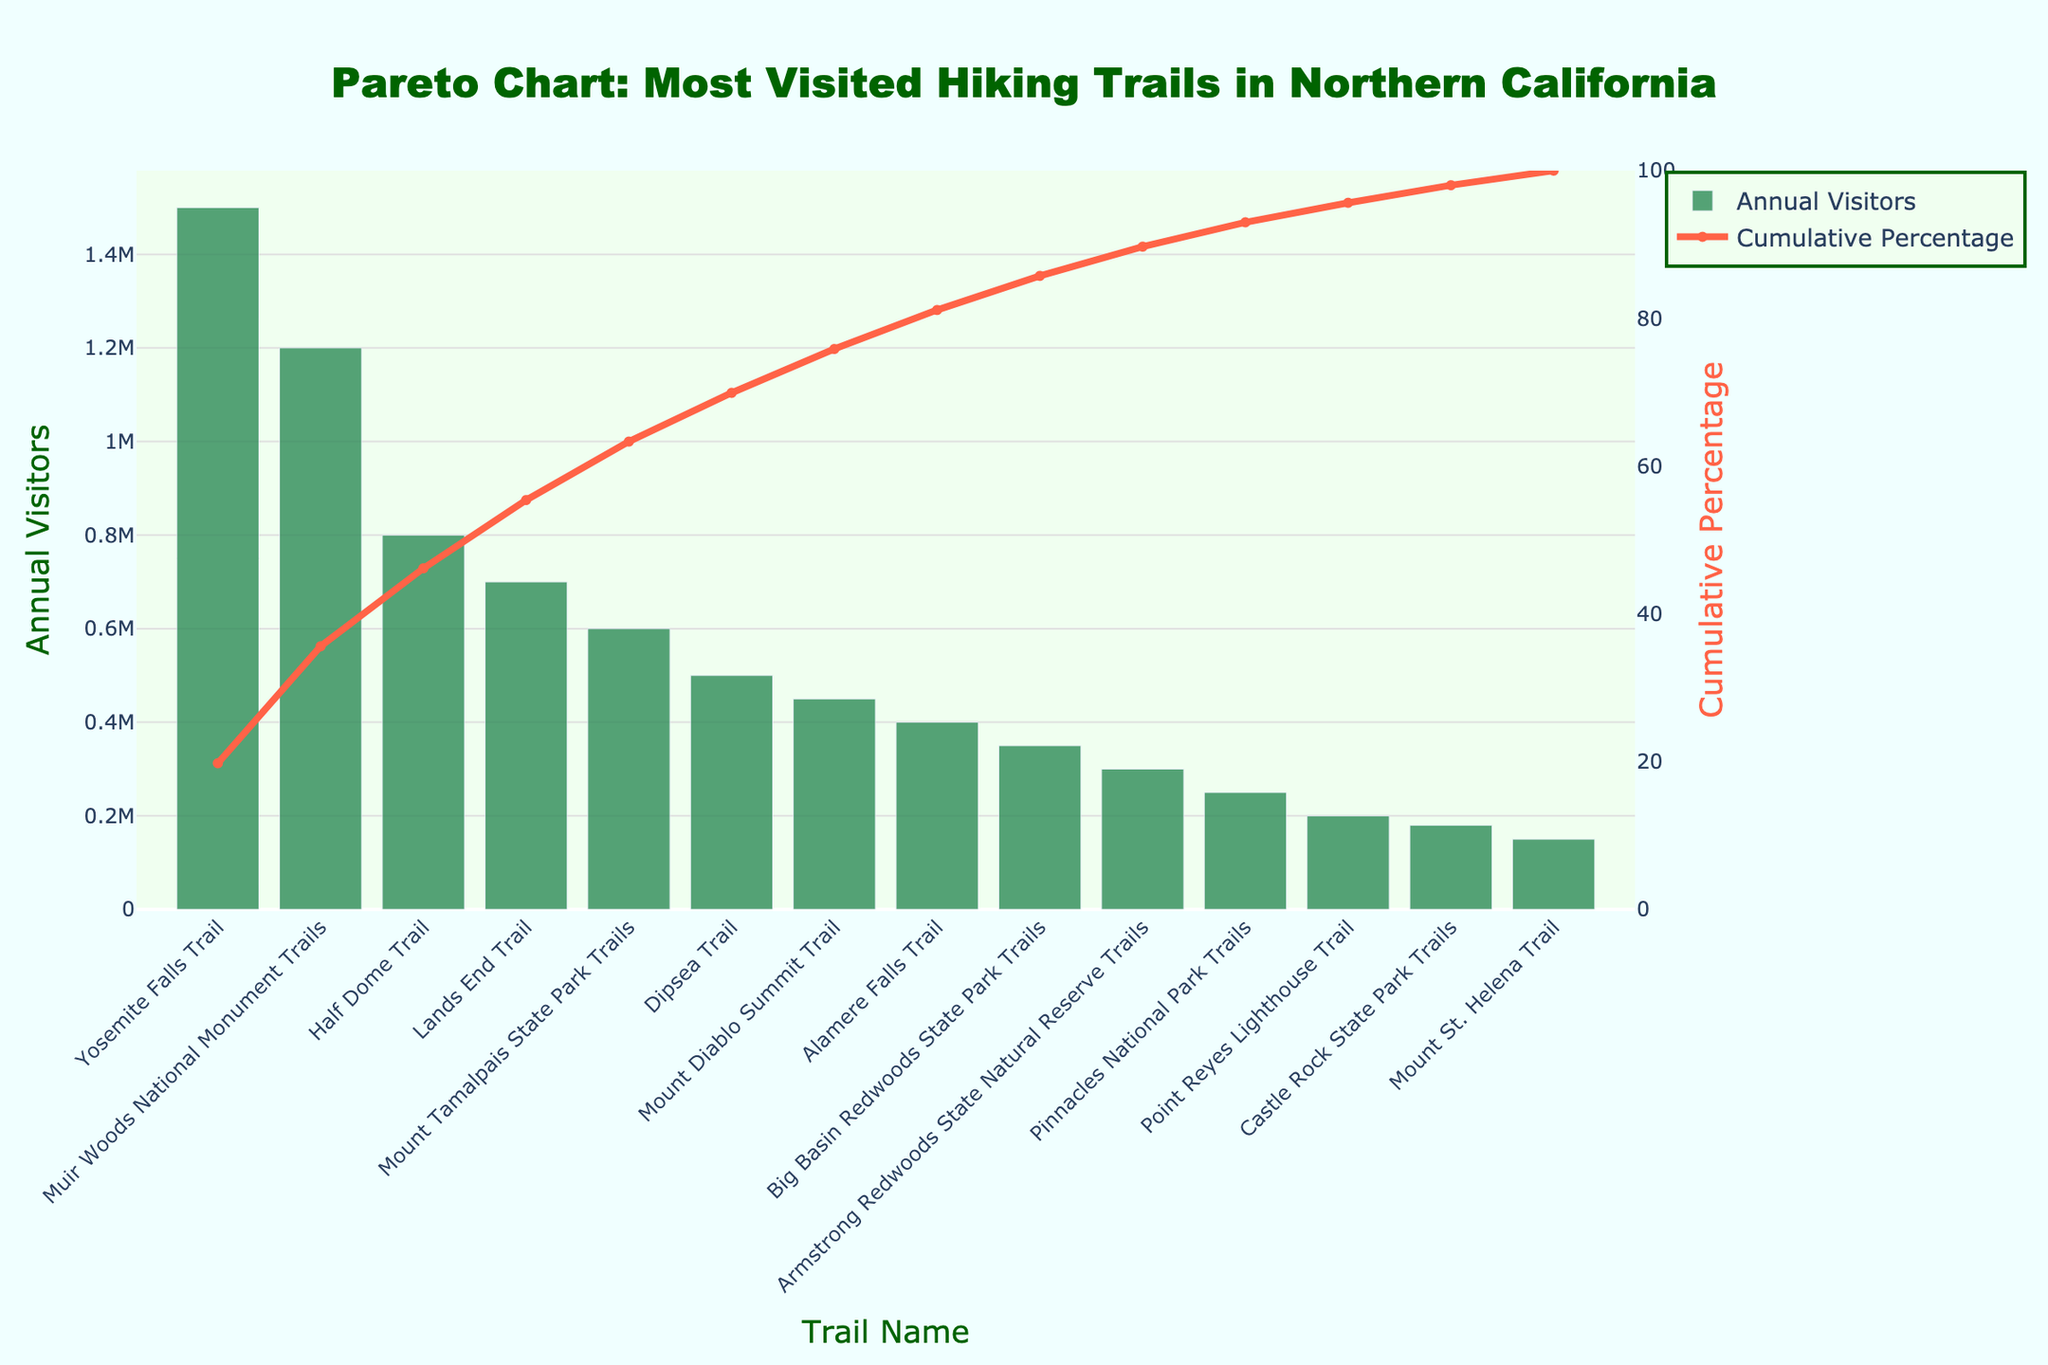How many hiking trails are shown in the Pareto chart? Count the number of bars displayed in the chart, as each bar represents a trail.
Answer: 14 What percentage of total visitors do the top three trails account for? Identify the cumulative percentage on the Y-axis for the third trail in the ranked list.
Answer: 66.66% Which trail has the highest annual visitor count? Look at the first bar in the Pareto chart which represents the trail with the most visitors.
Answer: Yosemite Falls Trail By how much does the annual visitor count of 'Yosemite Falls Trail' exceed 'Muir Woods National Monument Trails'? Subtract the annual visitor count of Muir Woods from Yosemite Falls Trail count.
Answer: 300,000 What is the cumulative percentage of visitors for the bottom five trails combined? Identify the cumulative percentage change from the 9th to the 14th bar and subtract the value at the 9th bar from that of the 14th bar.
Answer: 78.57% - 100% = 21.43% Which trail is the last to contribute to at least 80% of the cumulative visitors? Find the bar where the cumulative percentage crosses 80%.
Answer: Armstrong Redwoods State Natural Reserve Trails Is there a big drop-off in visitor numbers between any two consecutive trails in the chart? If so, where? Compare the heights or values of consecutive bars to identify any significant drops.
Answer: Between Muir Woods National Monument Trails and Half Dome Trail (400,000 difference) How many trails are needed to account for over 50% of the total visitors? Identify the bar where the cumulative percentage surpasses 50%.
Answer: 2 trails What is the approximate annual visitor count for 'Pinnacles National Park Trails'? Look for the height or value of the bar corresponding to the Pinnacles National Park Trails.
Answer: 250,000 Which trail has the fewest visitors, and what is its annual visitor count? Identify the last bar in the Pareto chart, which represents the trail with the fewest visitors.
Answer: Mount St. Helena Trail, 150,000 